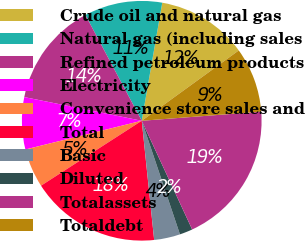<chart> <loc_0><loc_0><loc_500><loc_500><pie_chart><fcel>Crude oil and natural gas<fcel>Natural gas (including sales<fcel>Refined petroleum products<fcel>Electricity<fcel>Convenience store sales and<fcel>Total<fcel>Basic<fcel>Diluted<fcel>Totalassets<fcel>Totaldebt<nl><fcel>12.28%<fcel>10.53%<fcel>14.04%<fcel>7.02%<fcel>5.26%<fcel>17.54%<fcel>3.51%<fcel>1.75%<fcel>19.3%<fcel>8.77%<nl></chart> 